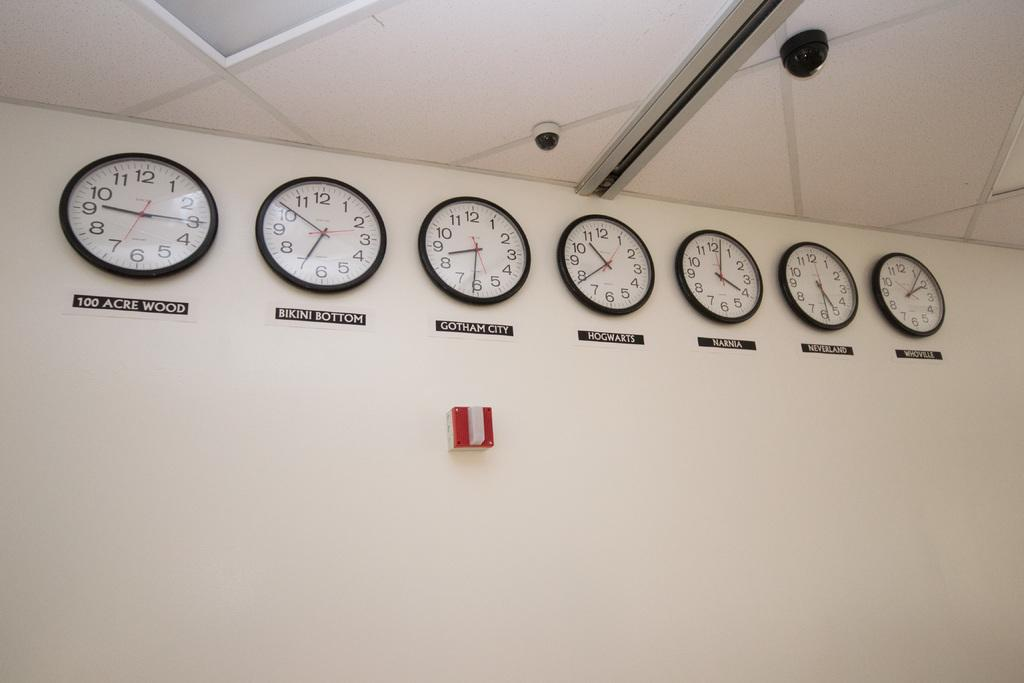Provide a one-sentence caption for the provided image. Seven clocks are lined up on wall and one shows the time for Bikini Bottom. 